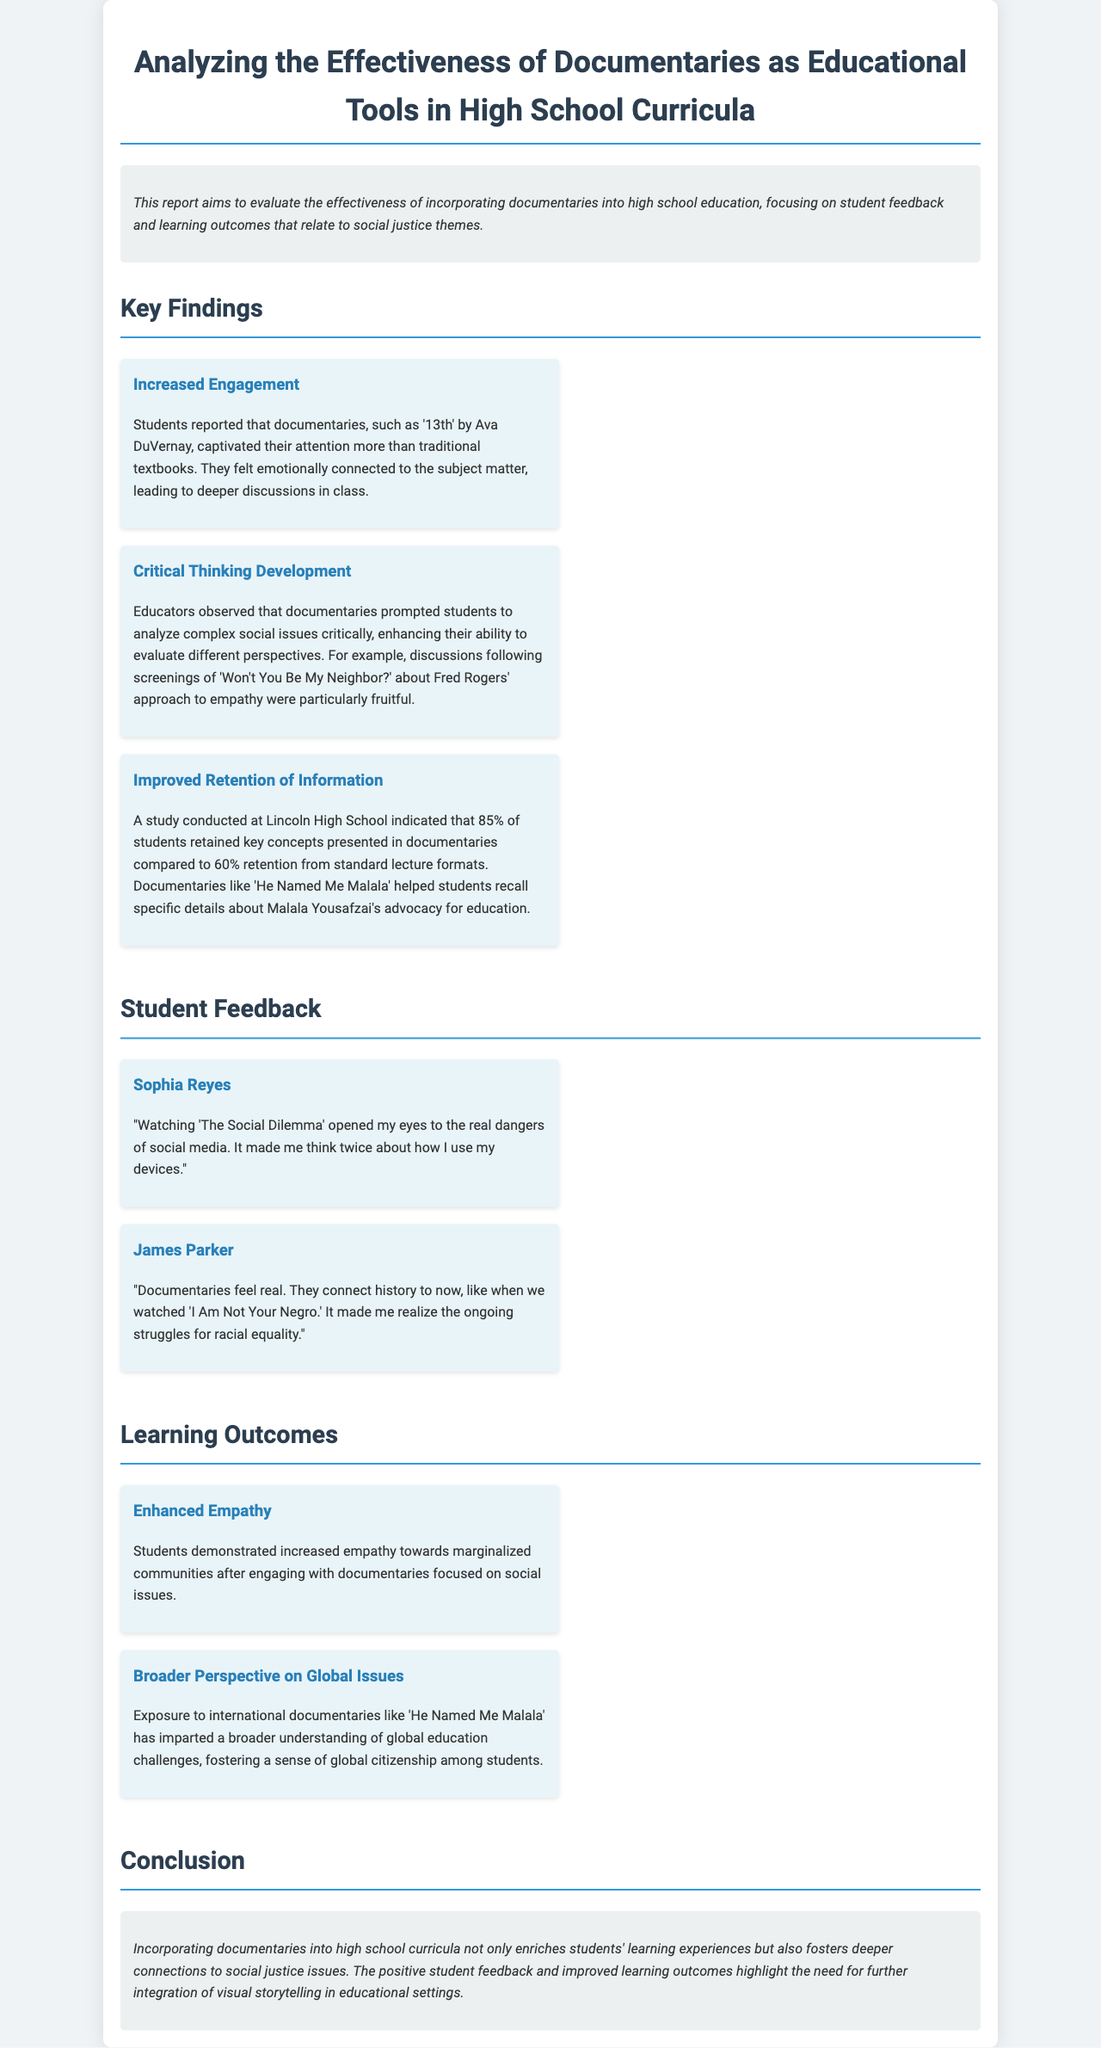What documentary is mentioned for its emotional connection? The document states that '13th' by Ava DuVernay captivated students' attention and led to deeper discussions in class.
Answer: '13th' What percentage of students retained information from documentaries? According to the report, 85% of students retained key concepts presented in documentaries compared to 60% retention from standard lectures.
Answer: 85% Who reflected on the dangers of social media? Sophia Reyes provided feedback that highlighted her awareness of the dangers of social media after watching a documentary.
Answer: Sophia Reyes Which documentary contributed to understanding global education challenges? The document indicates that 'He Named Me Malala' imparted a broader understanding of global education challenges.
Answer: 'He Named Me Malala' What positive outcome was demonstrated by students after engaging with documentaries? The report states that students showed enhanced empathy towards marginalized communities.
Answer: Enhanced Empathy What type of film did James Parker find to connect history to present-day struggles? The feedback from James Parker specified that 'I Am Not Your Negro' connected history to current racial equality struggles.
Answer: 'I Am Not Your Negro' Which educational approach was cited for improving critical thinking? The document emphasizes that documentaries prompted students to analyze complex social issues critically.
Answer: Documentaries What aspect of student learning is highlighted as improved from watching documentaries? The report notes improved retention of information when documentaries are used in education.
Answer: Retention of information 